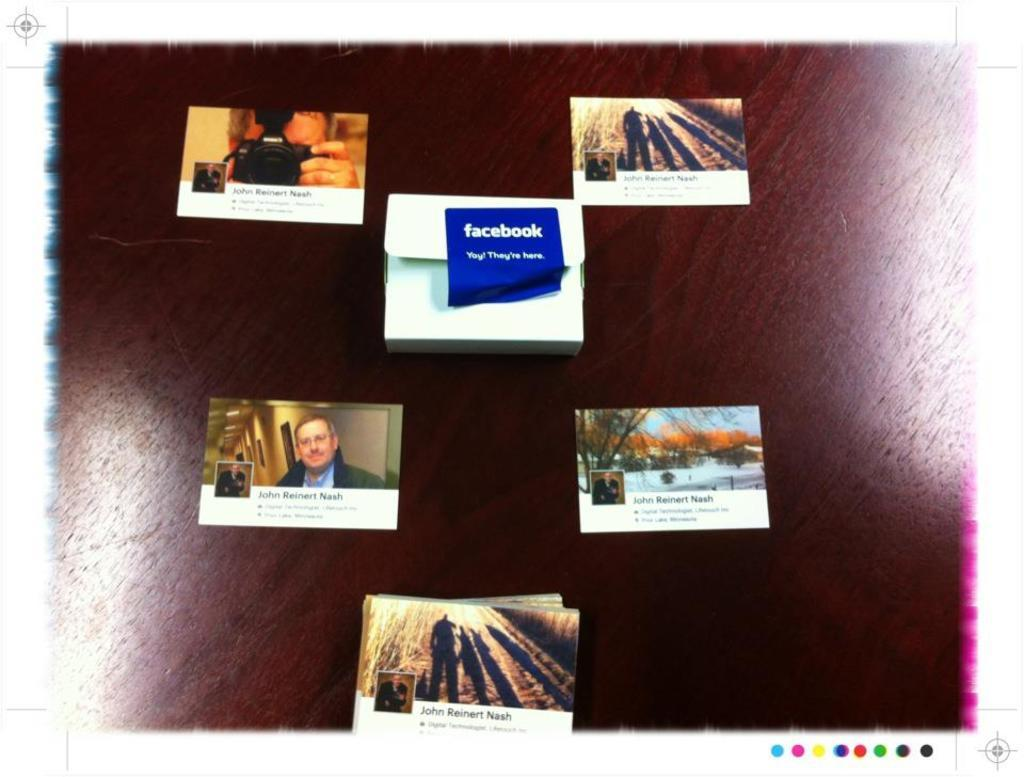<image>
Offer a succinct explanation of the picture presented. several pictures against a brown background, one showing a facebook logo 